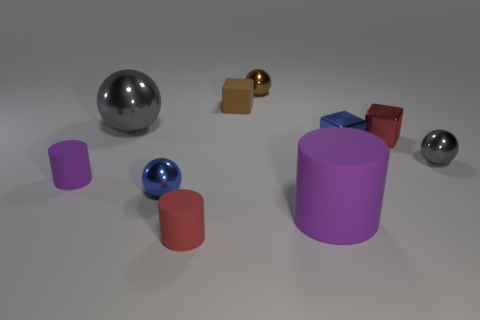What are the colors of the objects present in the image? The colors of the objects include silver, gold, red, blue, and purple. There are two silver spheres, a gold cube, a red cylinder, a blue sphere, a purple cylinder, a red cube, and a blue cube. Which color appears the most among the objects? The color red appears most frequently, present in two of the objects: one cylinder and one cube. 